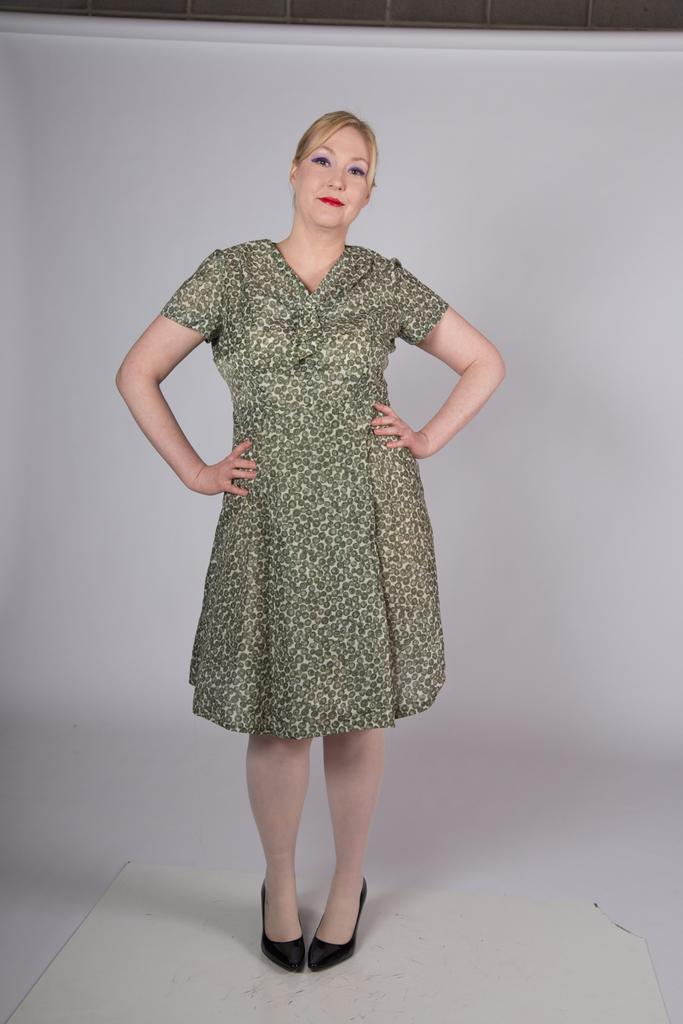Who is the main subject in the image? There is a woman in the image. What is the woman doing in the image? The woman is standing on the floor. What type of insurance does the woman have in the image? There is no information about insurance in the image; it only shows a woman standing on the floor. 